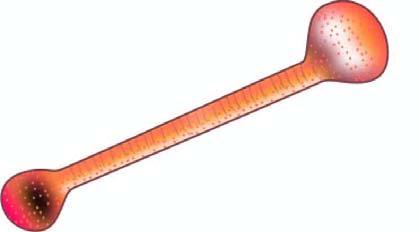s the interstitial vasculature an asbestos fibre coated with glycoprotein and haemosiderin giving it beaded or dumbbell-shaped appearance with bulbous ends?
Answer the question using a single word or phrase. No 